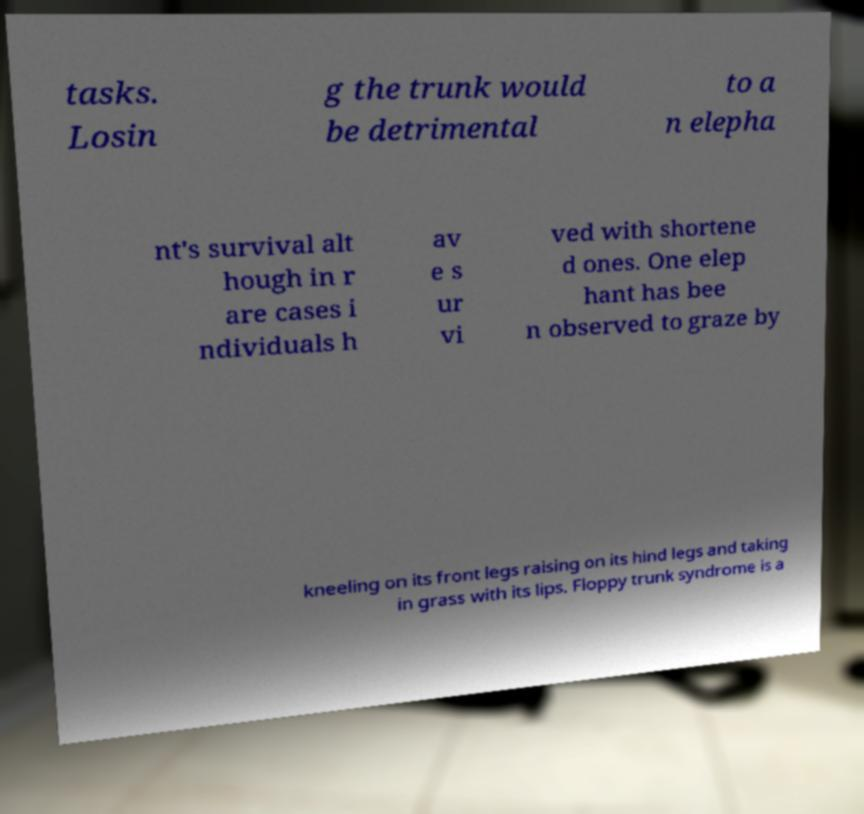There's text embedded in this image that I need extracted. Can you transcribe it verbatim? tasks. Losin g the trunk would be detrimental to a n elepha nt's survival alt hough in r are cases i ndividuals h av e s ur vi ved with shortene d ones. One elep hant has bee n observed to graze by kneeling on its front legs raising on its hind legs and taking in grass with its lips. Floppy trunk syndrome is a 